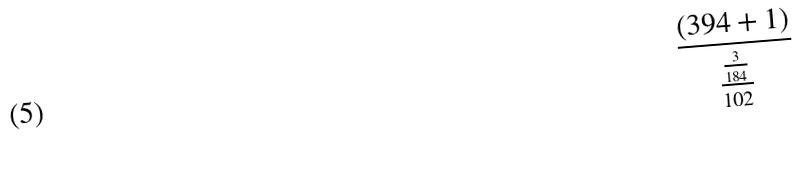<formula> <loc_0><loc_0><loc_500><loc_500>\frac { ( 3 9 4 + 1 ) } { \frac { \frac { 3 } { 1 8 4 } } { 1 0 2 } }</formula> 